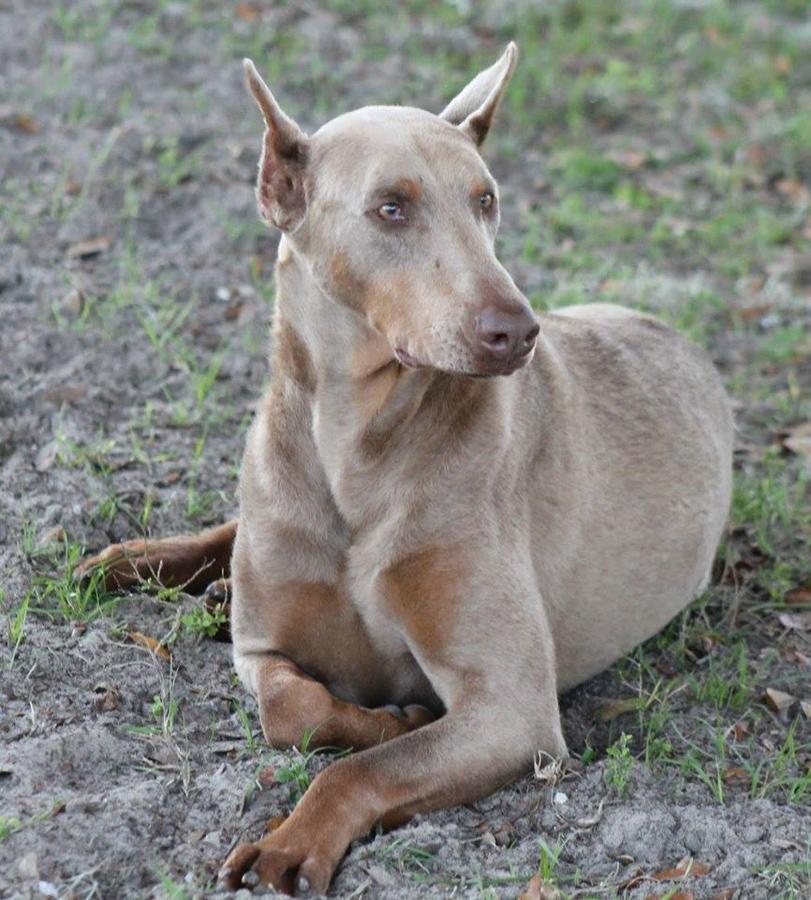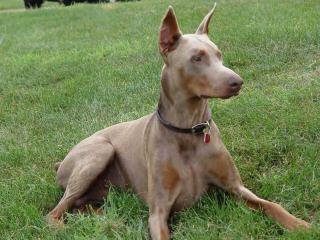The first image is the image on the left, the second image is the image on the right. Assess this claim about the two images: "A dog facing left and is near a man.". Correct or not? Answer yes or no. No. The first image is the image on the left, the second image is the image on the right. Considering the images on both sides, is "One image contains one pointy-eared doberman wearing a collar that has pale beige fur with mottled tan spots." valid? Answer yes or no. Yes. 